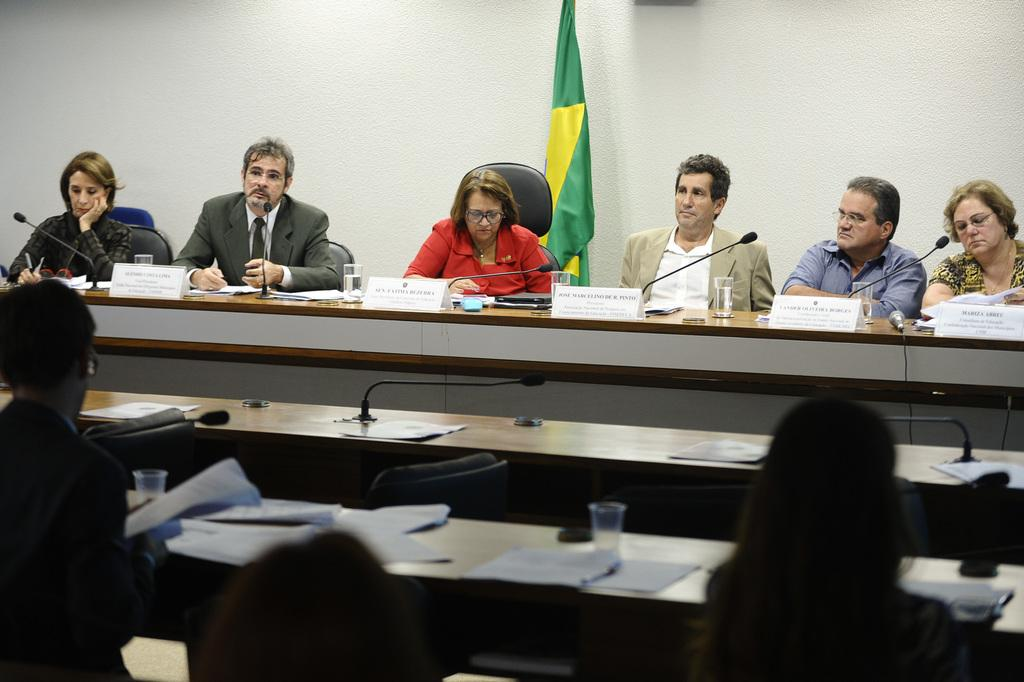What are the people in the image doing? The people in the image are sitting on chairs. What is present on the table in the image? There is a name plate, a microphone with a stand, a water glass, and papers on the table. What might be used for amplifying sound in the image? The microphone with a stand on the table might be used for amplifying sound. What can be used for drinking water in the image? The water glass on the table can be used for drinking water. Where is the mailbox located in the image? There is no mailbox present in the image. How many bikes are visible in the image? There are no bikes visible in the image. 